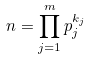Convert formula to latex. <formula><loc_0><loc_0><loc_500><loc_500>n = \prod _ { j = 1 } ^ { m } p _ { j } ^ { k _ { j } }</formula> 